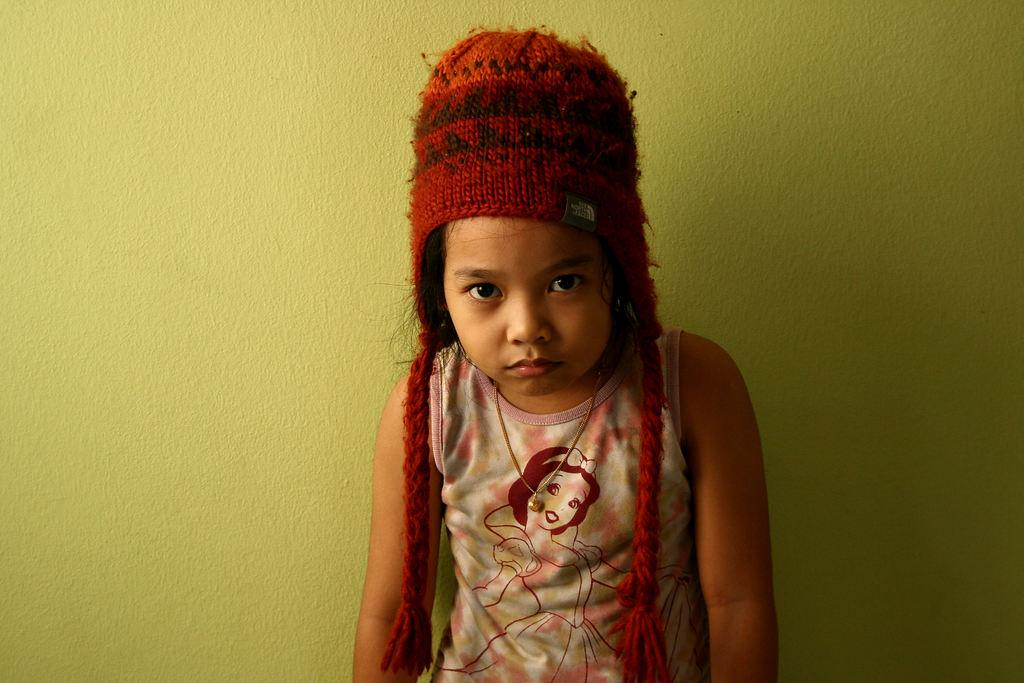What is the main subject of the image? The main subject of the image is a kid. What is the kid wearing on their head? The kid is wearing a woolen cap. What is the kid doing in the image? The kid is watching something. What can be seen in the background of the image? There is a wall in the background of the image. What type of feast is the kid attending in the image? There is no indication of a feast in the image; the kid is simply watching something. What is the kid's income in the image? The image does not provide any information about the kid's income. 